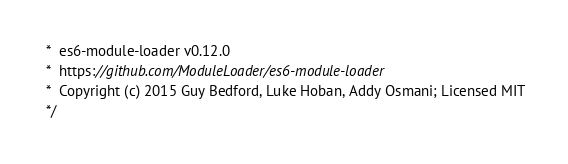Convert code to text. <code><loc_0><loc_0><loc_500><loc_500><_JavaScript_> *  es6-module-loader v0.12.0
 *  https://github.com/ModuleLoader/es6-module-loader
 *  Copyright (c) 2015 Guy Bedford, Luke Hoban, Addy Osmani; Licensed MIT
 */
</code> 